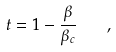<formula> <loc_0><loc_0><loc_500><loc_500>t = 1 - \frac { \beta } { \beta _ { c } } \quad ,</formula> 